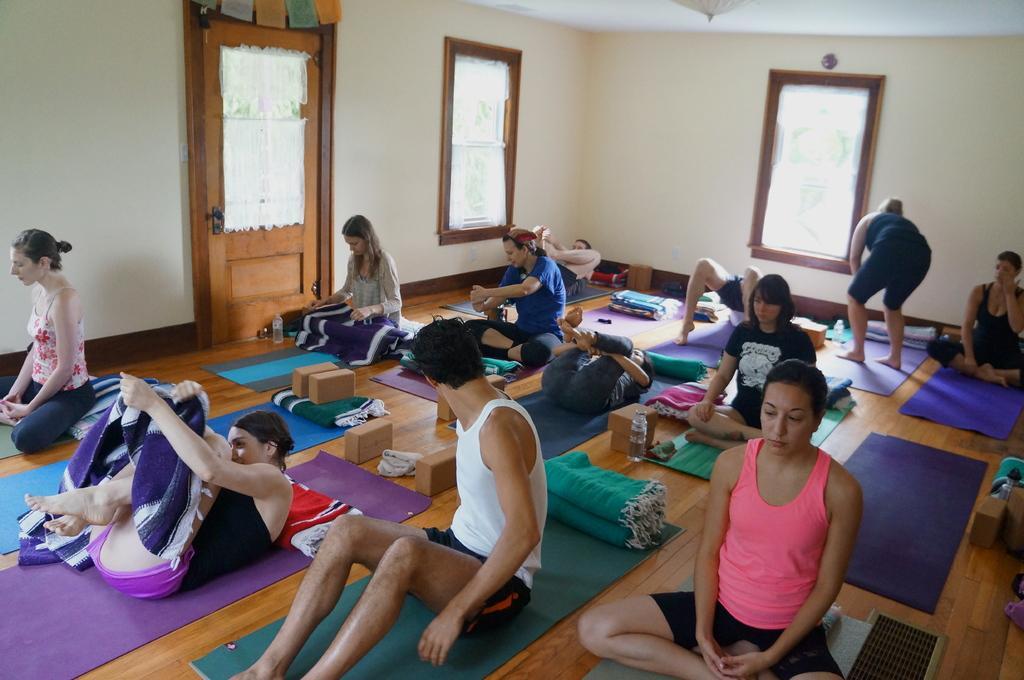How would you summarize this image in a sentence or two? In this picture there are people doing yoga and there is a person in squat position and we can see mats, bed sheets, bottles and objects on the floor. In the background of the image we can see windows, door and wall. 